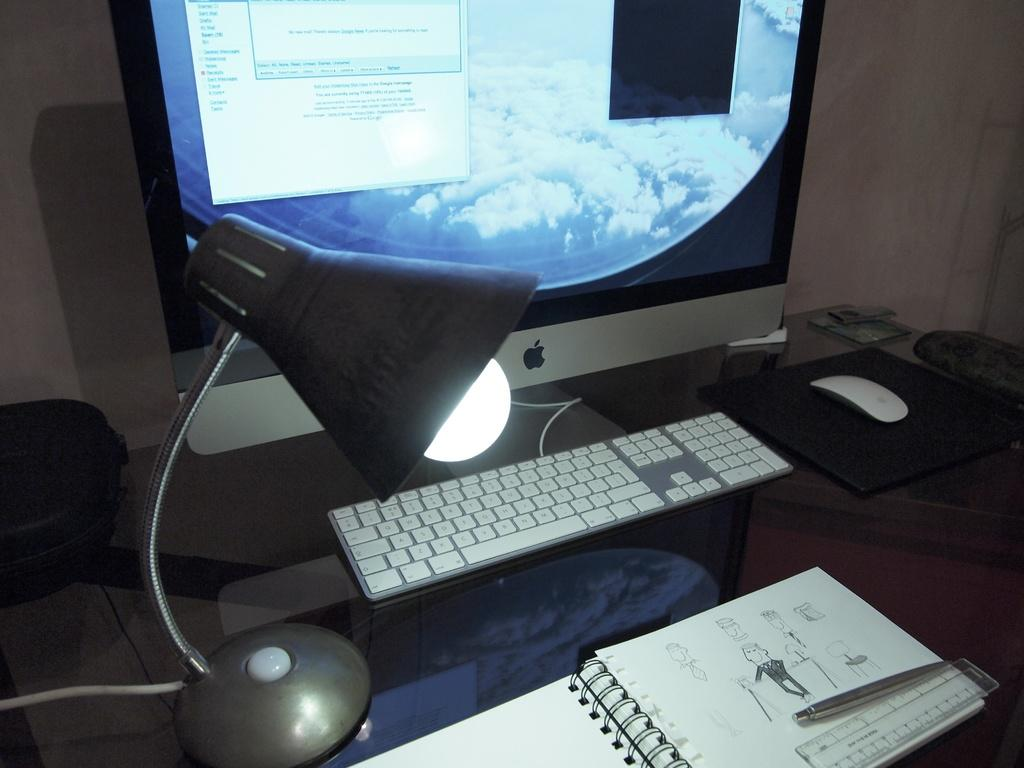What piece of furniture is present in the image? There is a table in the image. What items can be seen on the table? There is a book, a pen, a scale, a keyboard, a mouse, and a table lamp on the table. What electronic device is present on the table? There is a monitor on the table. What is the background of the image? There is a wall in the background of the image. What type of frame is hanging on the wall in the image? There is no frame hanging on the wall in the image. Can you tell me how many uncles are present in the image? There are no people, including uncles, present in the image. 